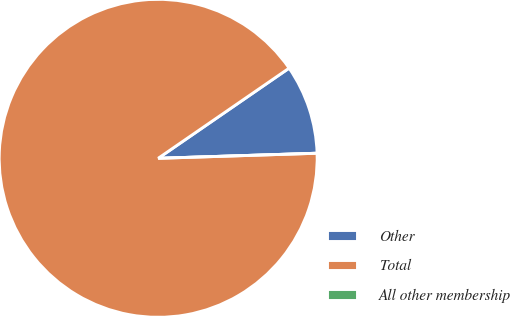Convert chart. <chart><loc_0><loc_0><loc_500><loc_500><pie_chart><fcel>Other<fcel>Total<fcel>All other membership<nl><fcel>9.09%<fcel>90.91%<fcel>0.0%<nl></chart> 